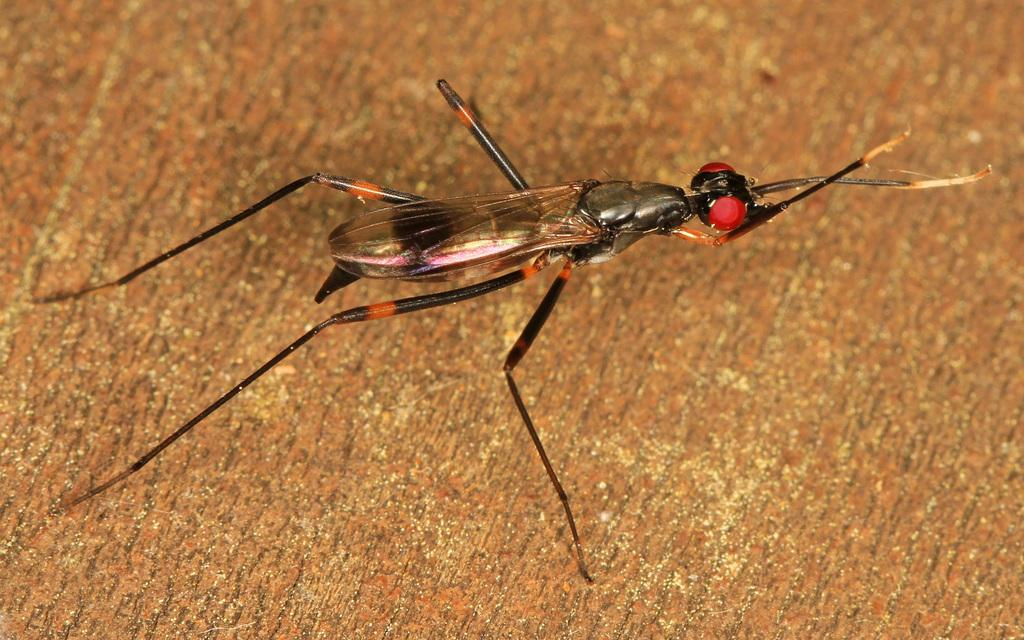What is the main subject of the picture? The main subject of the picture is an insect. Can you describe the insect's appearance? The insect has wings and long legs. What is the insect sitting on in the picture? The insect is sitting on a wooden substance. Can you tell me how many berries the girl is holding in the image? There is no girl or berries present in the image; it features an insect sitting on a wooden substance. What type of beetle is crawling on the wooden surface in the image? The insect in the image is not specifically identified as a beetle, and there is no mention of crawling. 